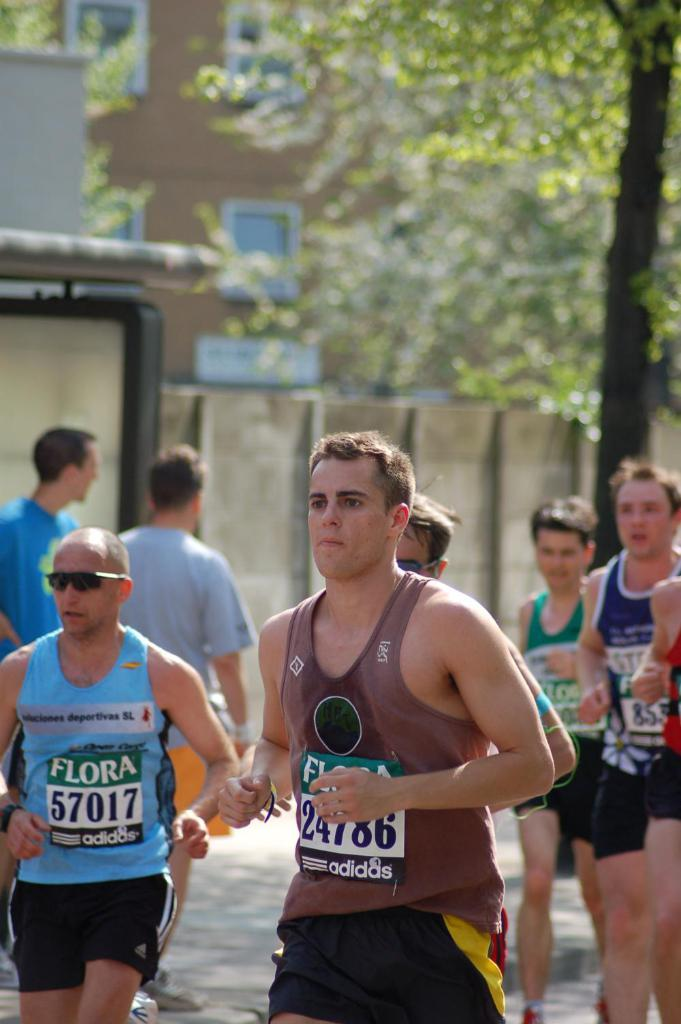How many people are in the image? There are persons in the image, but the exact number is not specified. What is located near the persons in the image? There is a wall in the image. What type of vegetation is visible in the image? There is a tree in the image. What can be seen in the distance in the image? There is a building in the background of the image. What type of pen is being used to draw on the wall in the image? There is no pen or drawing activity present in the image. What color is the chalk used to write on the tree in the image? There is no chalk or writing activity present on the tree in the image. 